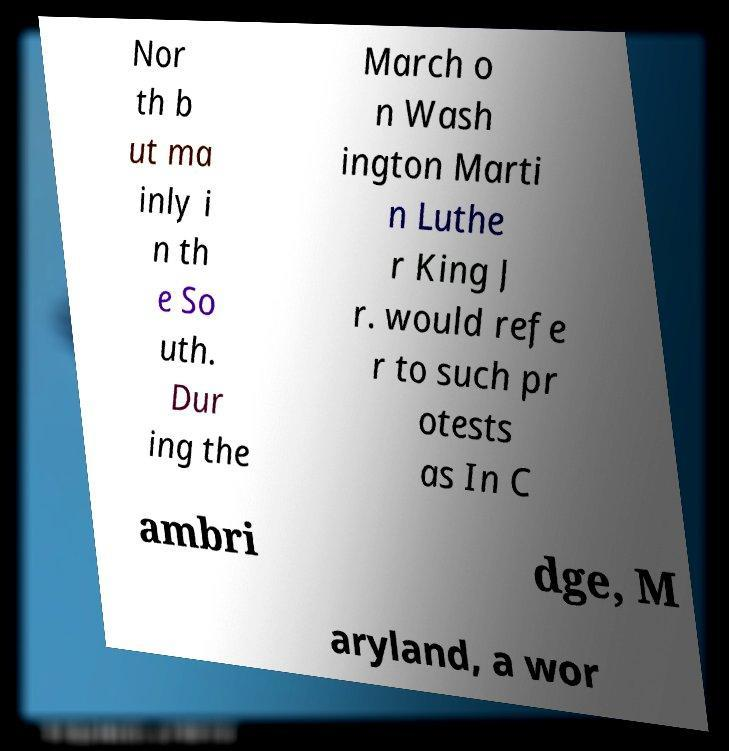Please read and relay the text visible in this image. What does it say? Nor th b ut ma inly i n th e So uth. Dur ing the March o n Wash ington Marti n Luthe r King J r. would refe r to such pr otests as In C ambri dge, M aryland, a wor 